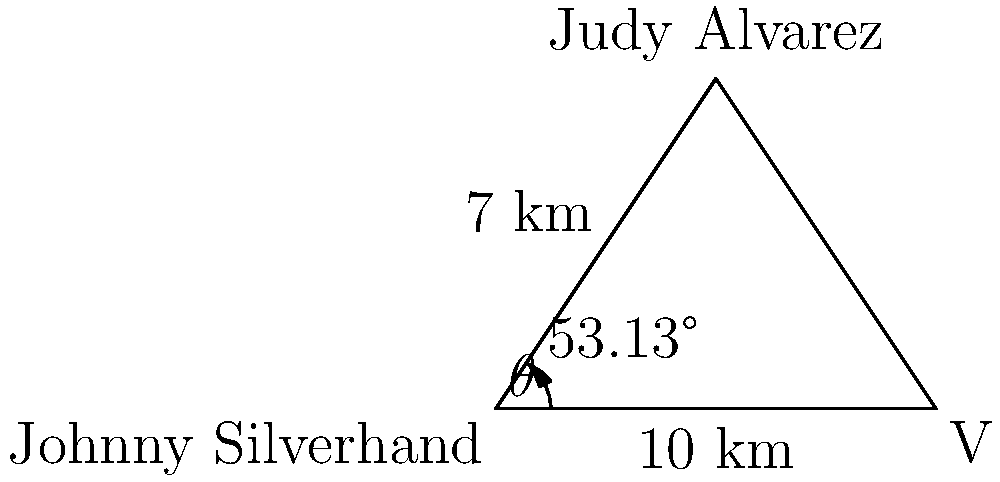In Night City, Johnny Silverhand and V are 10 km apart. Judy Alvarez is 7 km away from Johnny and forms a 53.13° angle with the line between Johnny and V. Using the law of cosines, calculate the distance between V and Judy. Round your answer to the nearest tenth of a kilometer. Let's approach this step-by-step using the law of cosines:

1) Let's define our variables:
   a = distance between V and Judy (what we're solving for)
   b = distance between Johnny and V (10 km)
   c = distance between Johnny and Judy (7 km)
   θ = angle between b and c (53.13°)

2) The law of cosines states:
   $$a^2 = b^2 + c^2 - 2bc \cos(\theta)$$

3) Let's substitute our known values:
   $$a^2 = 10^2 + 7^2 - 2(10)(7) \cos(53.13°)$$

4) Simplify:
   $$a^2 = 100 + 49 - 140 \cos(53.13°)$$

5) Calculate the cosine:
   $$\cos(53.13°) \approx 0.6$$

6) Substitute and calculate:
   $$a^2 = 100 + 49 - 140(0.6) = 149 - 84 = 65$$

7) Take the square root of both sides:
   $$a = \sqrt{65} \approx 8.06$$

8) Rounding to the nearest tenth:
   $$a \approx 8.1$$

Therefore, the distance between V and Judy is approximately 8.1 km.
Answer: 8.1 km 